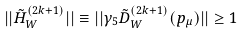Convert formula to latex. <formula><loc_0><loc_0><loc_500><loc_500>| | \tilde { H } ^ { ( 2 k + 1 ) } _ { W } | | \equiv | | \gamma _ { 5 } \tilde { D } _ { W } ^ { ( 2 k + 1 ) } ( p _ { \mu } ) | | \geq 1</formula> 